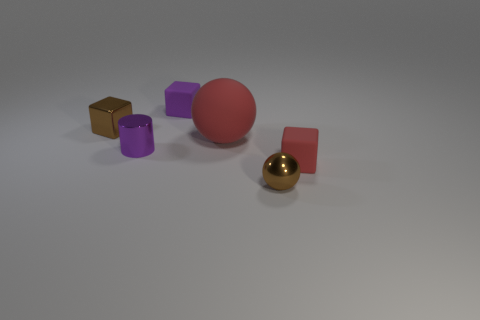How many other things are there of the same shape as the purple metallic object?
Provide a succinct answer. 0. Does the sphere that is in front of the tiny red matte object have the same material as the large red object?
Keep it short and to the point. No. Are there the same number of red objects to the right of the big red ball and tiny red things that are to the left of the metal cube?
Your response must be concise. No. What is the size of the purple cylinder in front of the tiny brown block?
Your response must be concise. Small. Are there any purple things made of the same material as the tiny brown block?
Provide a short and direct response. Yes. There is a small rubber thing that is in front of the shiny block; does it have the same color as the metal cylinder?
Give a very brief answer. No. Are there the same number of purple blocks that are behind the small purple block and large gray cylinders?
Ensure brevity in your answer.  Yes. Are there any blocks that have the same color as the small cylinder?
Your response must be concise. Yes. Is the size of the purple metal cylinder the same as the red rubber cube?
Provide a succinct answer. Yes. There is a red matte thing to the left of the tiny block in front of the large red rubber object; what size is it?
Provide a short and direct response. Large. 